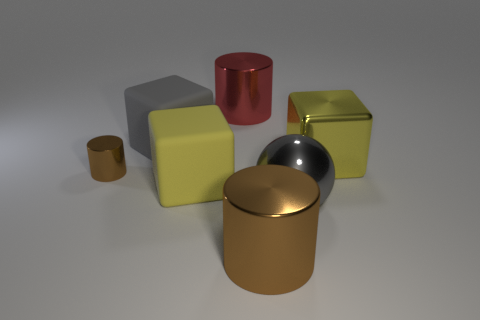Are there more matte things that are right of the yellow matte thing than large yellow metallic cubes that are left of the big gray rubber cube?
Make the answer very short. No. There is a large cylinder in front of the red object; what number of big yellow metallic cubes are in front of it?
Provide a succinct answer. 0. There is a large cylinder that is the same color as the tiny shiny cylinder; what material is it?
Make the answer very short. Metal. There is a block right of the large cylinder that is in front of the big yellow metallic block; what is its color?
Provide a short and direct response. Yellow. Are there any other spheres of the same color as the sphere?
Make the answer very short. No. What number of matte things are either balls or tiny brown cylinders?
Offer a terse response. 0. Is there a small brown cylinder made of the same material as the gray ball?
Make the answer very short. Yes. How many shiny objects are in front of the small brown object and behind the tiny shiny cylinder?
Make the answer very short. 0. Is the number of tiny brown metal cylinders to the right of the big brown thing less than the number of large rubber blocks that are left of the small brown metallic object?
Offer a very short reply. No. Does the small thing have the same shape as the gray shiny object?
Provide a succinct answer. No. 